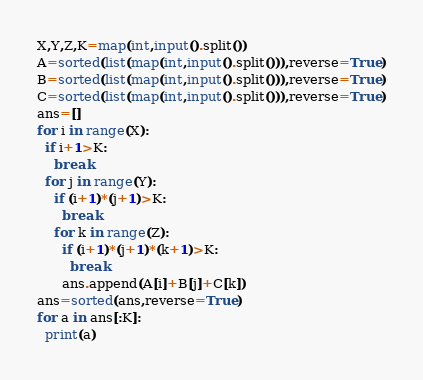<code> <loc_0><loc_0><loc_500><loc_500><_Python_>X,Y,Z,K=map(int,input().split())
A=sorted(list(map(int,input().split())),reverse=True)
B=sorted(list(map(int,input().split())),reverse=True)
C=sorted(list(map(int,input().split())),reverse=True)
ans=[]
for i in range(X):
  if i+1>K:
    break
  for j in range(Y):
    if (i+1)*(j+1)>K:
      break
    for k in range(Z):
      if (i+1)*(j+1)*(k+1)>K:
        break
      ans.append(A[i]+B[j]+C[k])
ans=sorted(ans,reverse=True)
for a in ans[:K]:
  print(a)</code> 